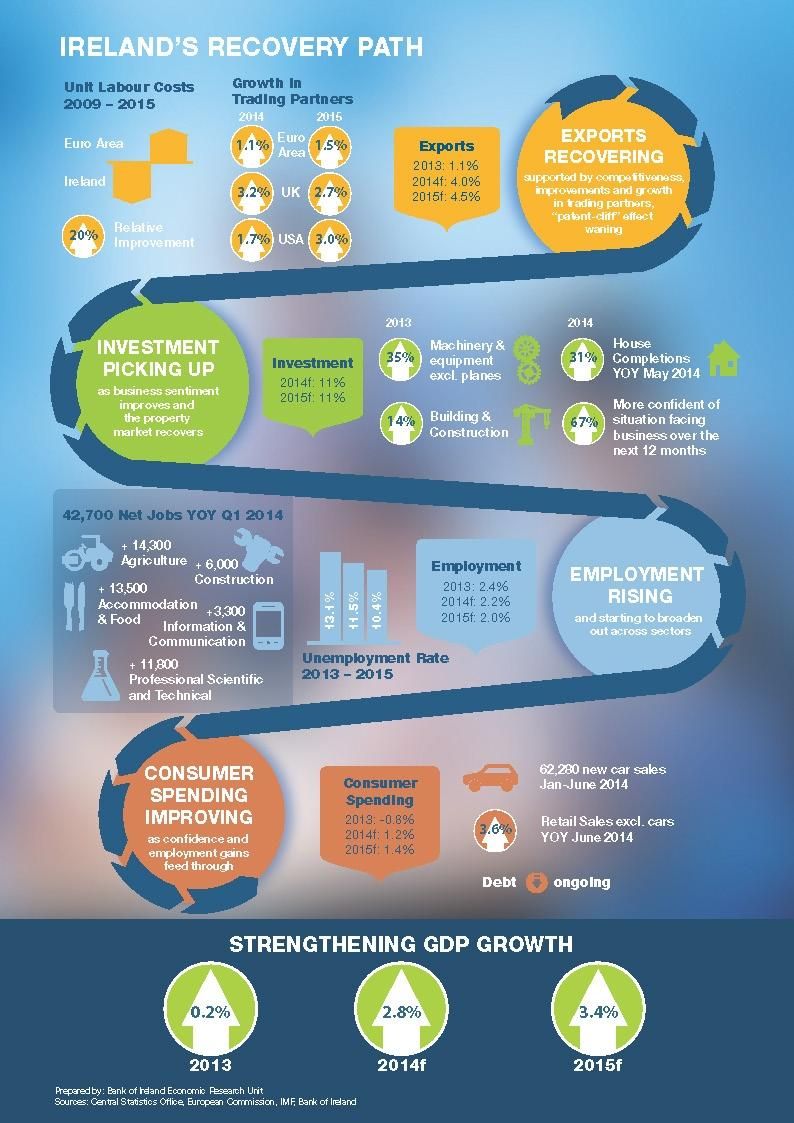Specify some key components in this picture. In 2015, the United States had a higher percentage of recovery compared to its trading partner. The unemployment rate was highest in 2013. In 2014, the Gross Domestic Product (GDP) growth was 2.8%. The increase in car sales was 3.6%. In 2013, the amount of machinery and equipment excluding planes that increased by 35% is [increased by 35%]. 